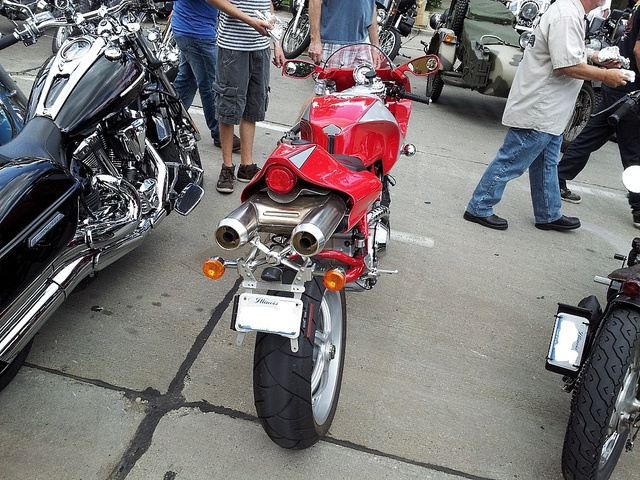Describe the objects in this image and their specific colors. I can see motorcycle in black, white, gray, and darkgray tones, motorcycle in black, gray, white, and darkgray tones, motorcycle in black, gray, white, and darkgray tones, people in black, lightgray, darkgray, gray, and blue tones, and motorcycle in black, gray, darkgray, and lightgray tones in this image. 